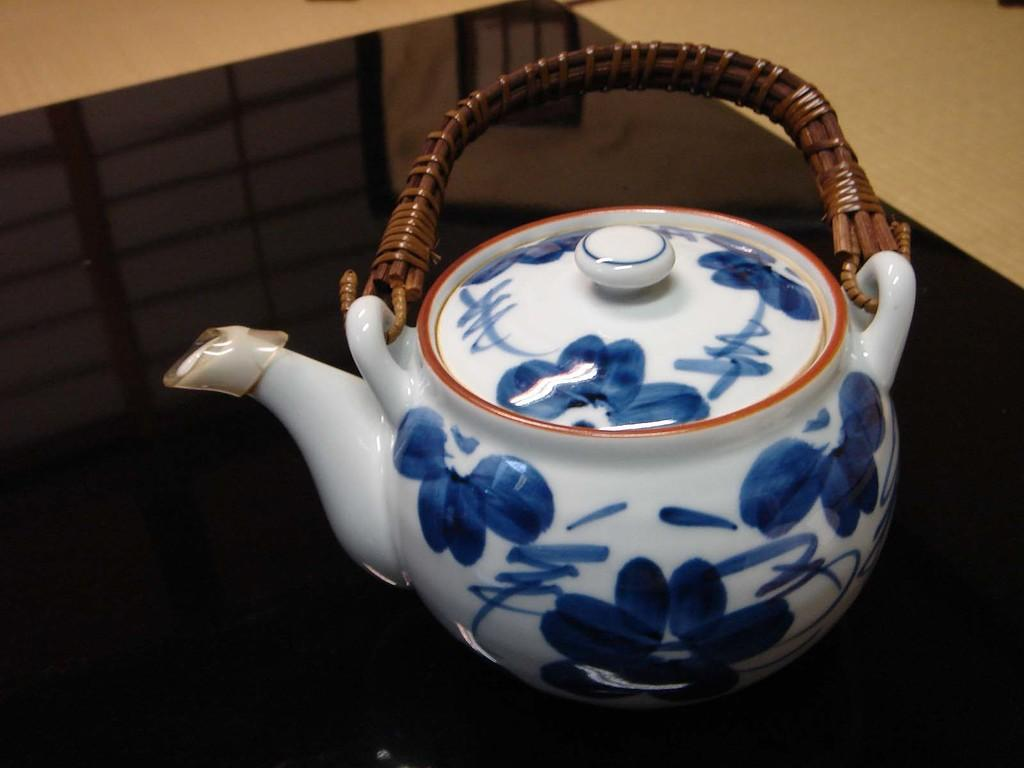What is on the table in the image? There is a kettle on a table in the image. What else can be seen in the image besides the kettle? The floor is visible in the image. What type of button is sewn onto the skirt in the image? There is no button or skirt present in the image; it only features a kettle on a table and the floor. 